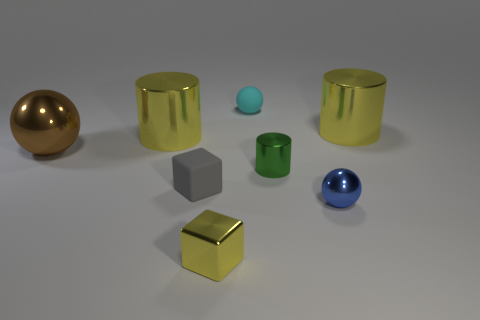Are there any small blue rubber cylinders? Upon reviewing the image, there are no objects that can be identified specifically as small blue rubber cylinders. However, there are various objects of different shapes and colors present, including what appears to be a small blue sphere. 